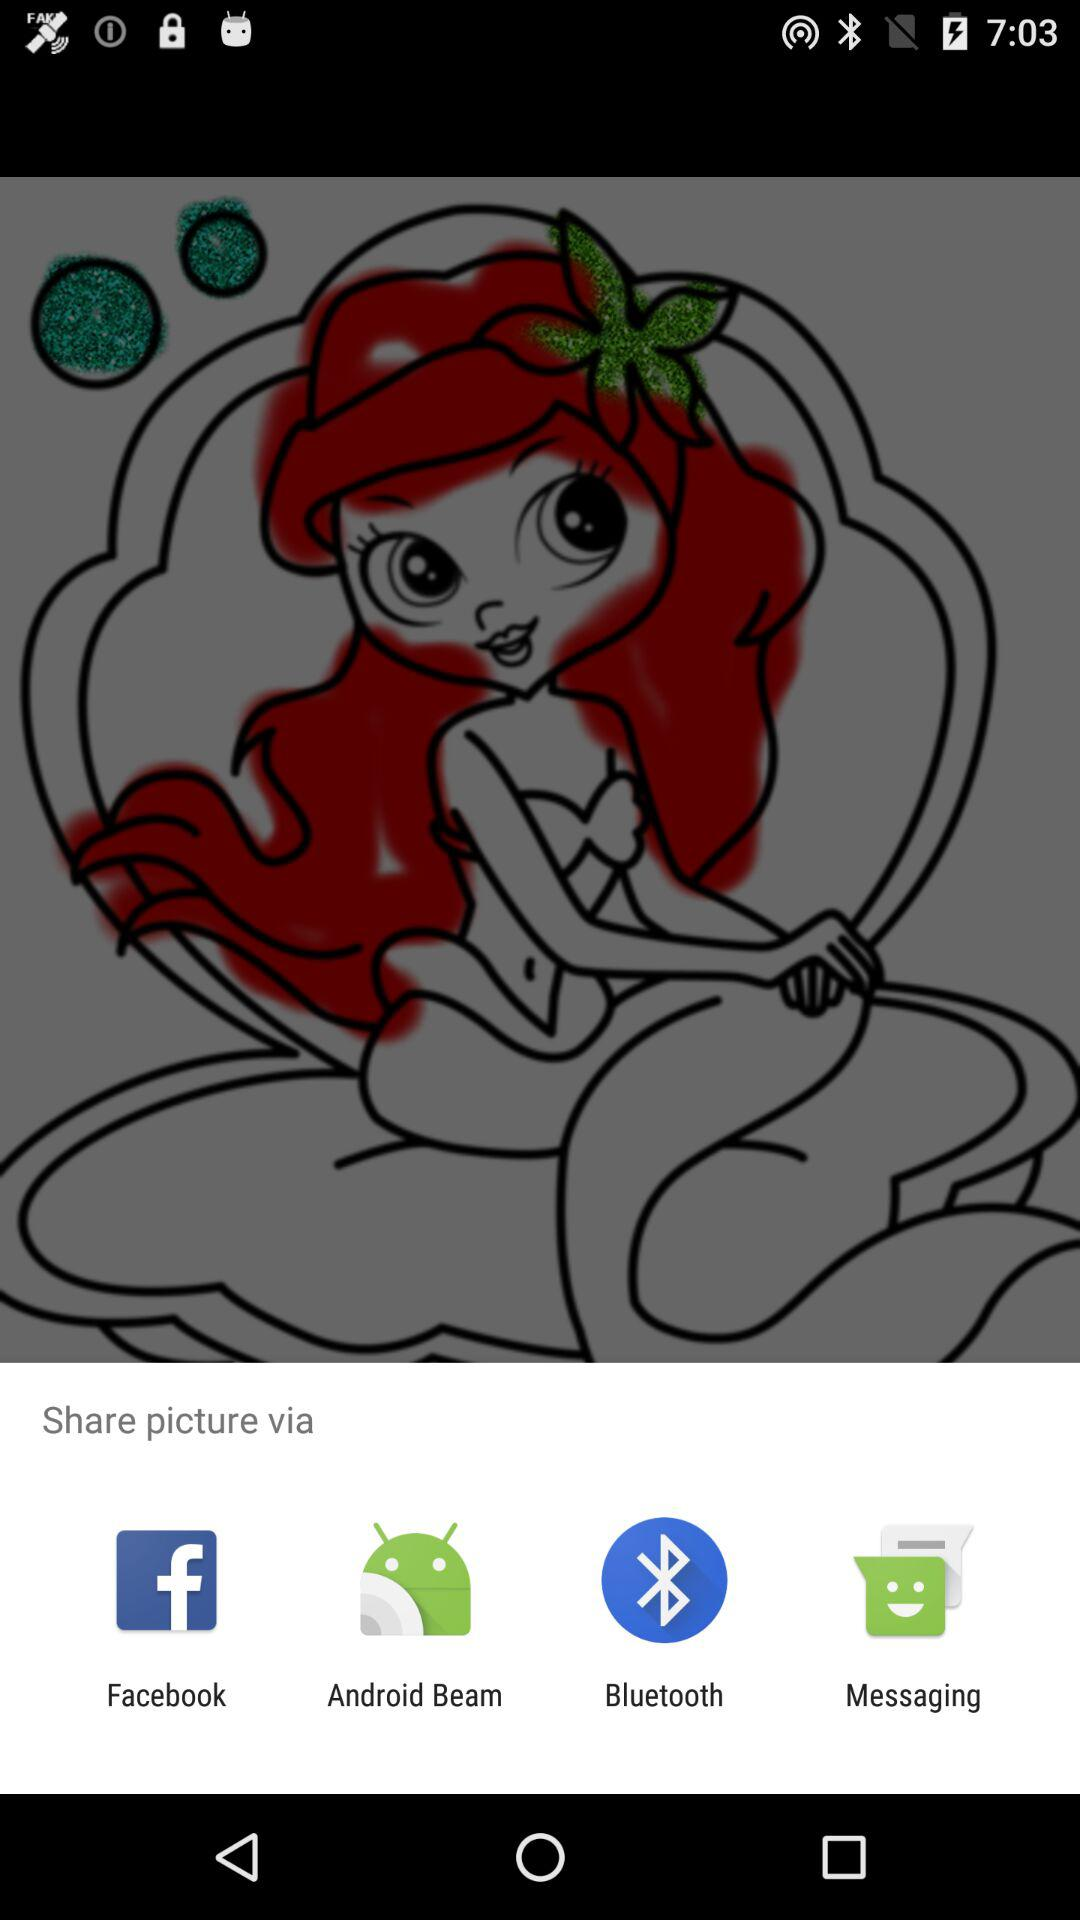Which applications can we use to share? You can use "Facebook", "Android Beam", "Bluetooth" and "Messaging" to share. 